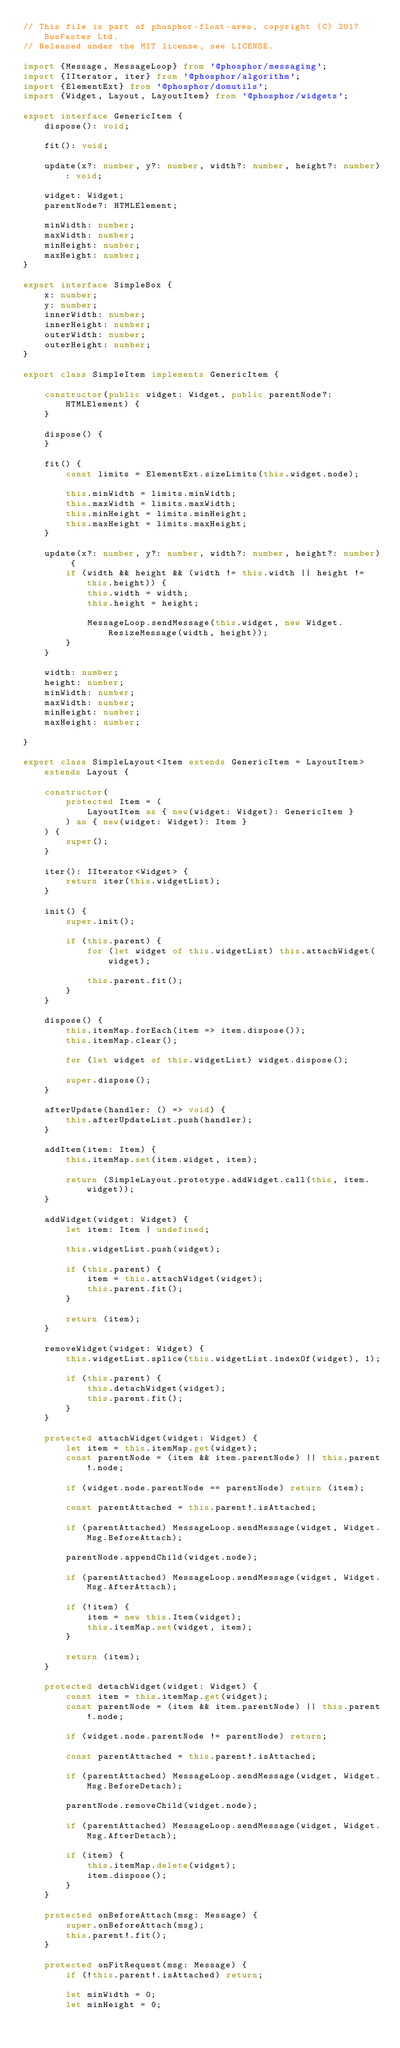Convert code to text. <code><loc_0><loc_0><loc_500><loc_500><_TypeScript_>// This file is part of phosphor-float-area, copyright (C) 2017 BusFaster Ltd.
// Released under the MIT license, see LICENSE.

import {Message, MessageLoop} from '@phosphor/messaging';
import {IIterator, iter} from '@phosphor/algorithm';
import {ElementExt} from '@phosphor/domutils';
import {Widget, Layout, LayoutItem} from '@phosphor/widgets';

export interface GenericItem {
    dispose(): void;

    fit(): void;

    update(x?: number, y?: number, width?: number, height?: number): void;

    widget: Widget;
    parentNode?: HTMLElement;

    minWidth: number;
    maxWidth: number;
    minHeight: number;
    maxHeight: number;
}

export interface SimpleBox {
    x: number;
    y: number;
    innerWidth: number;
    innerHeight: number;
    outerWidth: number;
    outerHeight: number;
}

export class SimpleItem implements GenericItem {

    constructor(public widget: Widget, public parentNode?: HTMLElement) {
    }

    dispose() {
    }

    fit() {
        const limits = ElementExt.sizeLimits(this.widget.node);

        this.minWidth = limits.minWidth;
        this.maxWidth = limits.maxWidth;
        this.minHeight = limits.minHeight;
        this.maxHeight = limits.maxHeight;
    }

    update(x?: number, y?: number, width?: number, height?: number) {
        if (width && height && (width != this.width || height != this.height)) {
            this.width = width;
            this.height = height;

            MessageLoop.sendMessage(this.widget, new Widget.ResizeMessage(width, height));
        }
    }

    width: number;
    height: number;
    minWidth: number;
    maxWidth: number;
    minHeight: number;
    maxHeight: number;

}

export class SimpleLayout<Item extends GenericItem = LayoutItem> extends Layout {

    constructor(
        protected Item = (
            LayoutItem as { new(widget: Widget): GenericItem }
        ) as { new(widget: Widget): Item }
    ) {
        super();
    }

    iter(): IIterator<Widget> {
        return iter(this.widgetList);
    }

    init() {
        super.init();

        if (this.parent) {
            for (let widget of this.widgetList) this.attachWidget(widget);

            this.parent.fit();
        }
    }

    dispose() {
        this.itemMap.forEach(item => item.dispose());
        this.itemMap.clear();

        for (let widget of this.widgetList) widget.dispose();

        super.dispose();
    }

    afterUpdate(handler: () => void) {
        this.afterUpdateList.push(handler);
    }

    addItem(item: Item) {
        this.itemMap.set(item.widget, item);

        return (SimpleLayout.prototype.addWidget.call(this, item.widget));
    }

    addWidget(widget: Widget) {
        let item: Item | undefined;

        this.widgetList.push(widget);

        if (this.parent) {
            item = this.attachWidget(widget);
            this.parent.fit();
        }

        return (item);
    }

    removeWidget(widget: Widget) {
        this.widgetList.splice(this.widgetList.indexOf(widget), 1);

        if (this.parent) {
            this.detachWidget(widget);
            this.parent.fit();
        }
    }

    protected attachWidget(widget: Widget) {
        let item = this.itemMap.get(widget);
        const parentNode = (item && item.parentNode) || this.parent!.node;

        if (widget.node.parentNode == parentNode) return (item);

        const parentAttached = this.parent!.isAttached;

        if (parentAttached) MessageLoop.sendMessage(widget, Widget.Msg.BeforeAttach);

        parentNode.appendChild(widget.node);

        if (parentAttached) MessageLoop.sendMessage(widget, Widget.Msg.AfterAttach);

        if (!item) {
            item = new this.Item(widget);
            this.itemMap.set(widget, item);
        }

        return (item);
    }

    protected detachWidget(widget: Widget) {
        const item = this.itemMap.get(widget);
        const parentNode = (item && item.parentNode) || this.parent!.node;

        if (widget.node.parentNode != parentNode) return;

        const parentAttached = this.parent!.isAttached;

        if (parentAttached) MessageLoop.sendMessage(widget, Widget.Msg.BeforeDetach);

        parentNode.removeChild(widget.node);

        if (parentAttached) MessageLoop.sendMessage(widget, Widget.Msg.AfterDetach);

        if (item) {
            this.itemMap.delete(widget);
            item.dispose();
        }
    }

    protected onBeforeAttach(msg: Message) {
        super.onBeforeAttach(msg);
        this.parent!.fit();
    }

    protected onFitRequest(msg: Message) {
        if (!this.parent!.isAttached) return;

        let minWidth = 0;
        let minHeight = 0;</code> 